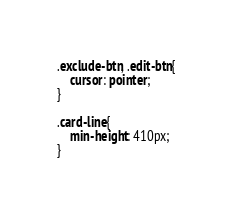Convert code to text. <code><loc_0><loc_0><loc_500><loc_500><_CSS_>
.exclude-btn, .edit-btn{
    cursor: pointer;
}

.card-line{
    min-height: 410px;
}

</code> 